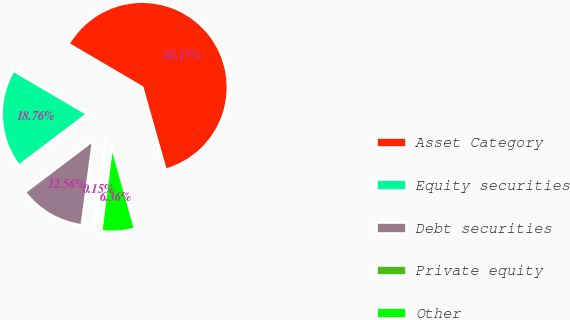Convert chart. <chart><loc_0><loc_0><loc_500><loc_500><pie_chart><fcel>Asset Category<fcel>Equity securities<fcel>Debt securities<fcel>Private equity<fcel>Other<nl><fcel>62.17%<fcel>18.76%<fcel>12.56%<fcel>0.15%<fcel>6.36%<nl></chart> 